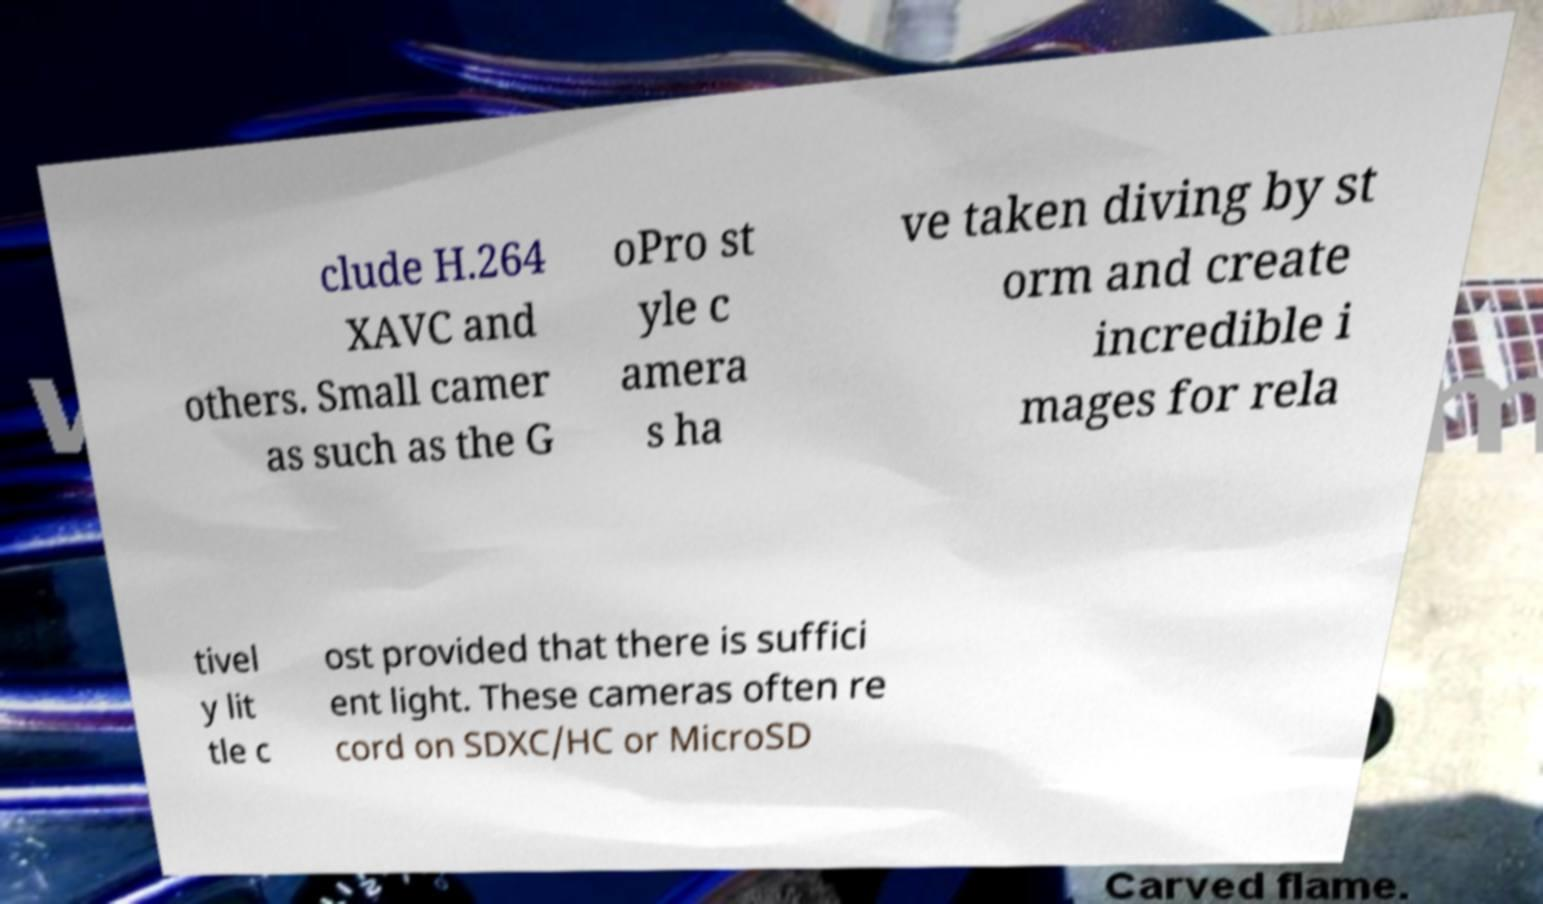Could you extract and type out the text from this image? clude H.264 XAVC and others. Small camer as such as the G oPro st yle c amera s ha ve taken diving by st orm and create incredible i mages for rela tivel y lit tle c ost provided that there is suffici ent light. These cameras often re cord on SDXC/HC or MicroSD 